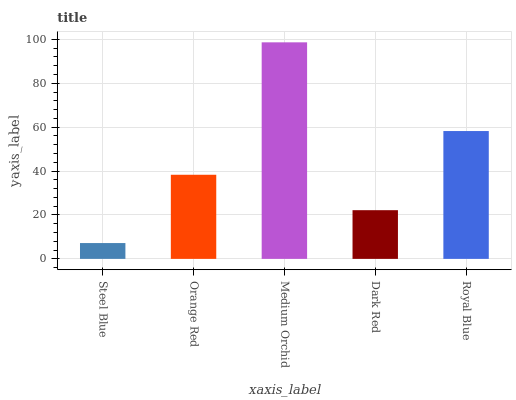Is Steel Blue the minimum?
Answer yes or no. Yes. Is Medium Orchid the maximum?
Answer yes or no. Yes. Is Orange Red the minimum?
Answer yes or no. No. Is Orange Red the maximum?
Answer yes or no. No. Is Orange Red greater than Steel Blue?
Answer yes or no. Yes. Is Steel Blue less than Orange Red?
Answer yes or no. Yes. Is Steel Blue greater than Orange Red?
Answer yes or no. No. Is Orange Red less than Steel Blue?
Answer yes or no. No. Is Orange Red the high median?
Answer yes or no. Yes. Is Orange Red the low median?
Answer yes or no. Yes. Is Steel Blue the high median?
Answer yes or no. No. Is Royal Blue the low median?
Answer yes or no. No. 